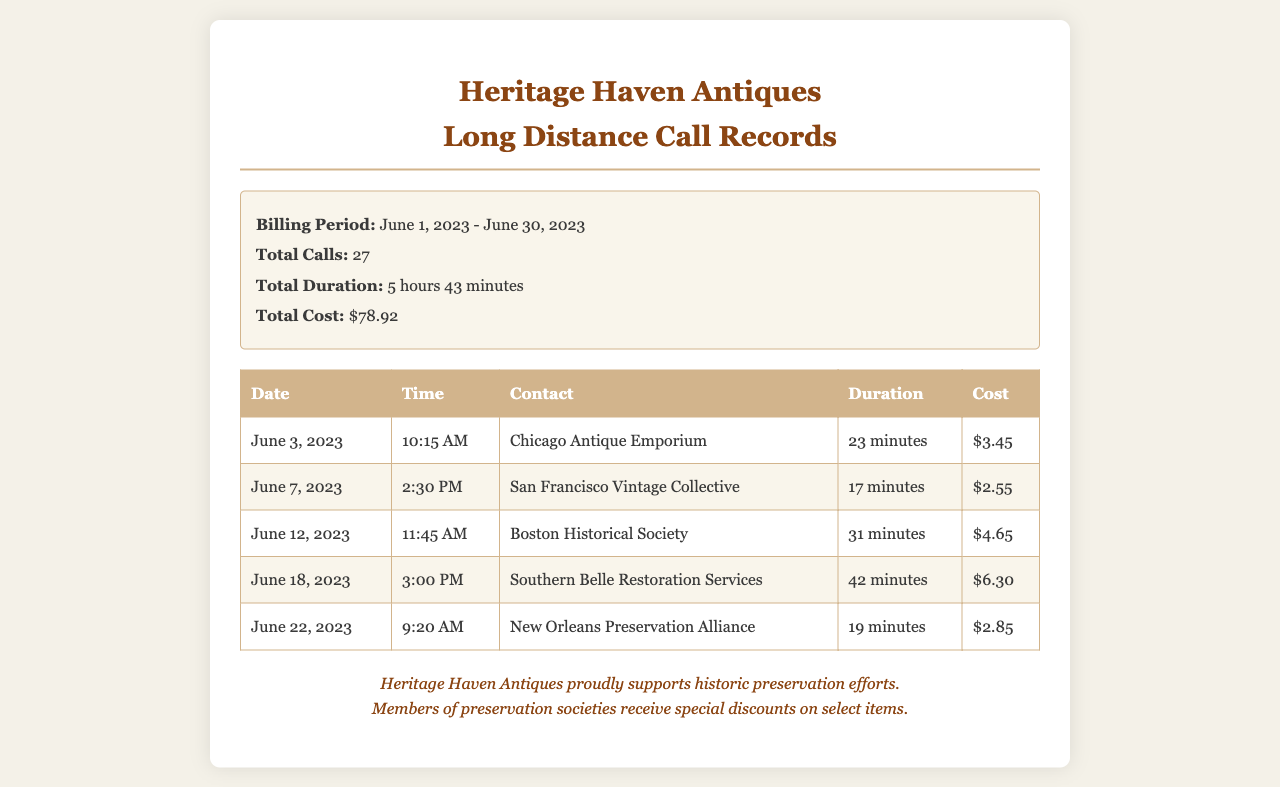What is the total cost of long-distance calls? The total cost is provided in the summary section, which states it is $78.92.
Answer: $78.92 How many total calls were made? The total number of calls is mentioned in the summary section, which shows 27 calls were made.
Answer: 27 Which supplier was contacted on June 18, 2023? The contact name for that date is found in the table, which lists Southern Belle Restoration Services.
Answer: Southern Belle Restoration Services What was the duration of the call to Boston Historical Society? The duration is specified in the table as 31 minutes.
Answer: 31 minutes What is the billing period for these call records? The billing period is stated in the summary as June 1, 2023 - June 30, 2023.
Answer: June 1, 2023 - June 30, 2023 What was the cost of the call made on June 22, 2023? The cost is given in the table, which shows it was $2.85.
Answer: $2.85 Which call had the highest duration? The longest call is identified as the one with Southern Belle Restoration Services for 42 minutes.
Answer: 42 minutes How many minutes were spent in total on calls during the billing period? The total duration is summed up in the summary, listing it as 5 hours 43 minutes.
Answer: 5 hours 43 minutes What type of discounts does Heritage Haven Antiques offer? The type of discount is mentioned in the footer, referring to special discounts for members of preservation societies.
Answer: Special discounts for members 